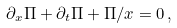Convert formula to latex. <formula><loc_0><loc_0><loc_500><loc_500>\partial _ { x } \Pi + \partial _ { t } \Pi + \Pi / x = 0 \, ,</formula> 